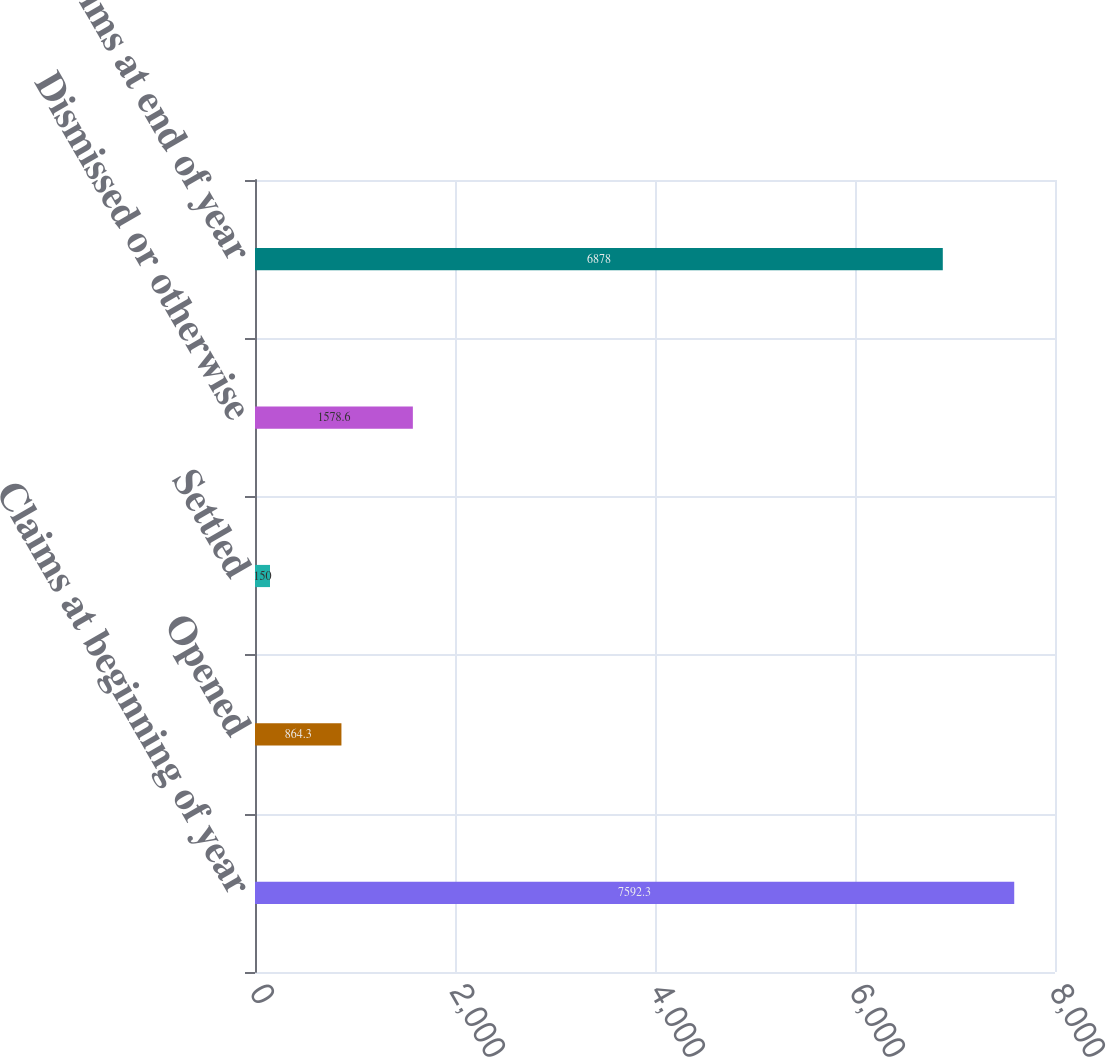Convert chart to OTSL. <chart><loc_0><loc_0><loc_500><loc_500><bar_chart><fcel>Claims at beginning of year<fcel>Opened<fcel>Settled<fcel>Dismissed or otherwise<fcel>Claims at end of year<nl><fcel>7592.3<fcel>864.3<fcel>150<fcel>1578.6<fcel>6878<nl></chart> 